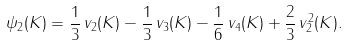<formula> <loc_0><loc_0><loc_500><loc_500>\psi _ { 2 } ( K ) = \frac { 1 } { 3 } \, v _ { 2 } ( K ) - \frac { 1 } { 3 } \, v _ { 3 } ( K ) - \frac { 1 } { 6 } \, v _ { 4 } ( K ) + \frac { 2 } { 3 } \, v _ { 2 } ^ { 2 } ( K ) .</formula> 